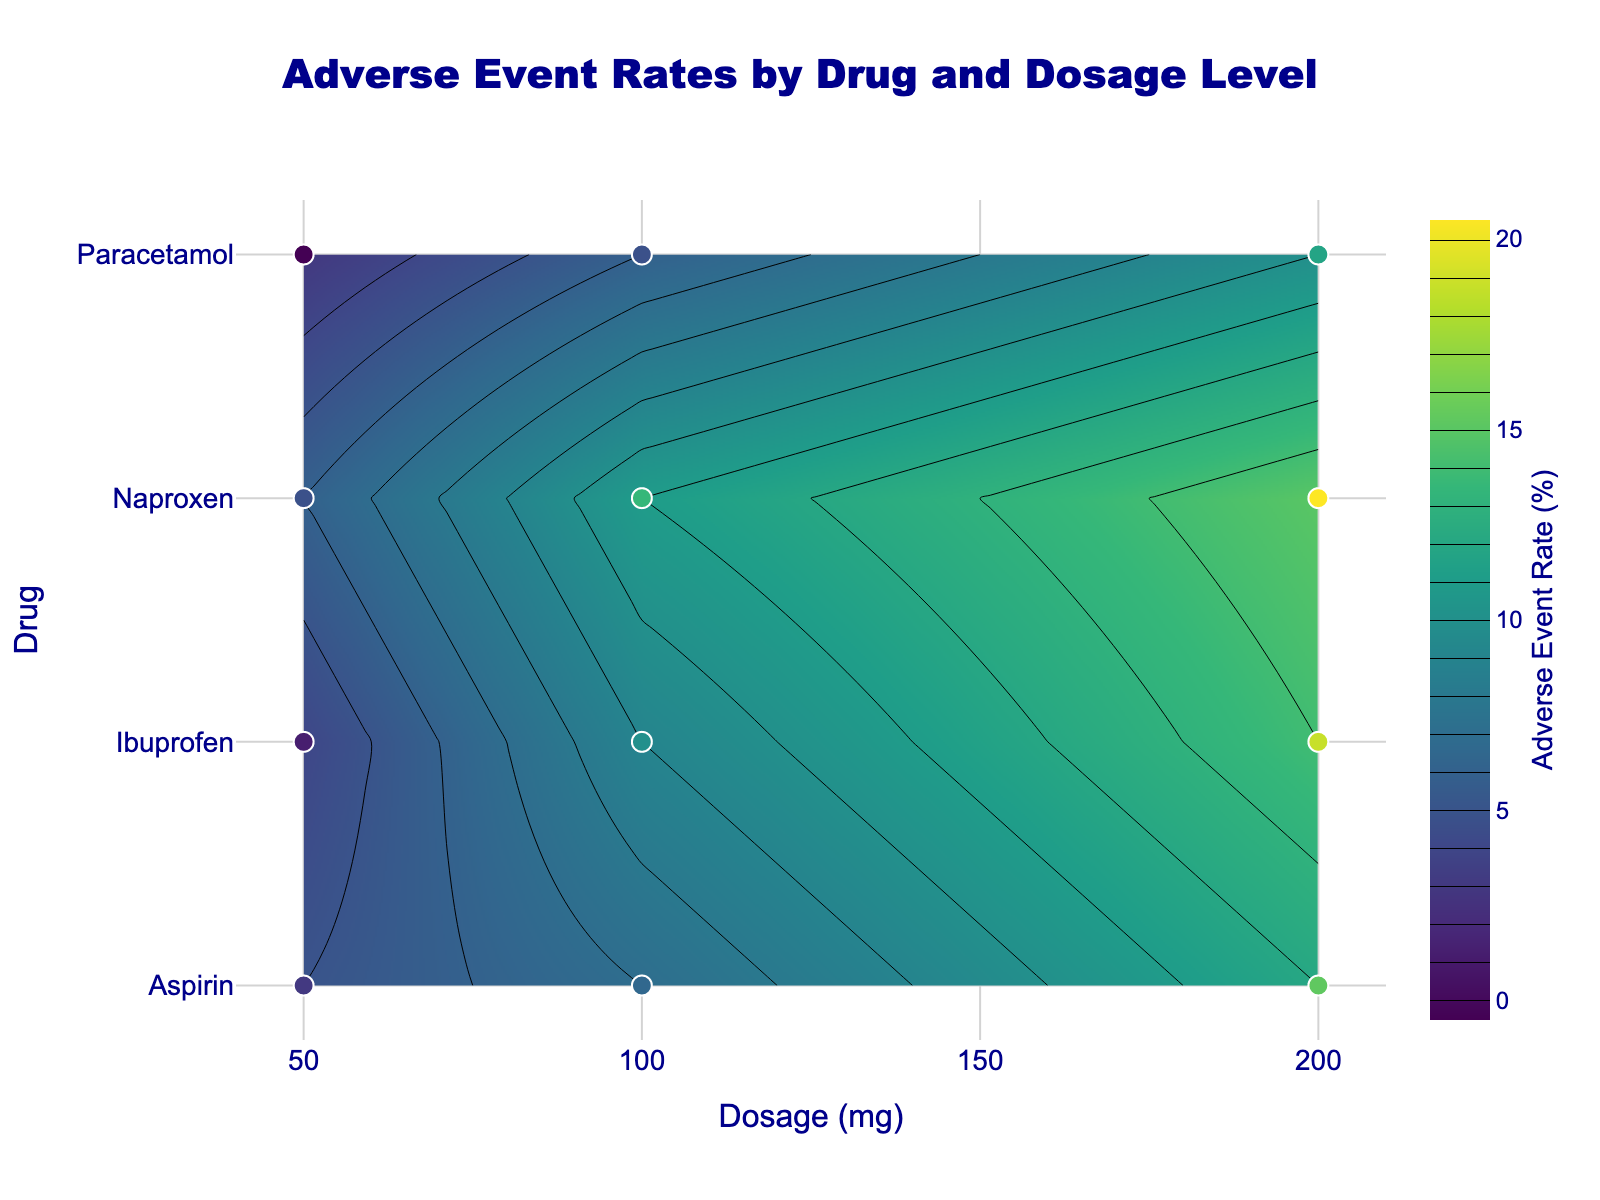What is the title of the figure? The title is usually displayed at the top of the figure. In this case, it's centered and in dark blue color.
Answer: Adverse Event Rates by Drug and Dosage Level What are the x-axis and y-axis labels? The x-axis is labeled "Dosage (mg)" and the y-axis is labeled "Drug". These labels describe what each axis represents.
Answer: Dosage (mg), Drug Which drug has the highest adverse event rate at 200 mg dosage? To find this, look at the contour lines at 200 mg dosage on the x-axis and check which drug corresponds to the highest value on the y-axis.
Answer: Naproxen How many data points are there for each drug? We observe markers on the plot, and each drug has three markers corresponding to different dosages (50, 100, 200 mg). Since there are four drugs, each one has three data points.
Answer: 3 Which drug shows the smallest increase in adverse event rate between 50 mg and 200 mg? Compare the difference in adverse event rates between 50 mg and 200 mg for each drug. Paracetamol goes from 3% to 10%, which is the smallest increase.
Answer: Paracetamol At which dosage does Ibuprofen have an adverse event rate of 9%? Locate Ibuprofen on the y-axis and then find the dosage on the x-axis that corresponds to the 9% event rate contour line.
Answer: 100 mg Between Paracetamol and Aspirin, which drug has a higher adverse event rate at 100 mg? Compare the positions on the contour lines at 100 mg dosage. Paracetamol has 6%, while Aspirin has 7%.
Answer: Aspirin What is the color associated with an adverse event rate of 12% on the color scale? Locate the 12% rate on the color bar to determine the associated color. It generally appears in the middle range of the Viridis scale, likely a greenish-yellow.
Answer: Greenish-yellow Which drug has the most gradual increase in adverse event rate as the dosage increases? Examine the steepness of the contour lines for each drug. Paracetamol's contour lines are the furthest apart, indicating a more gradual increase.
Answer: Paracetamol How does the adverse event rate for Naproxen change from 50 mg to 200 mg? Observe the contour lines for Naproxen at these dosages. The adverse event rate starts at 6% at 50 mg and increases significantly to 15% at 200 mg.
Answer: Increases from 6% to 15% 